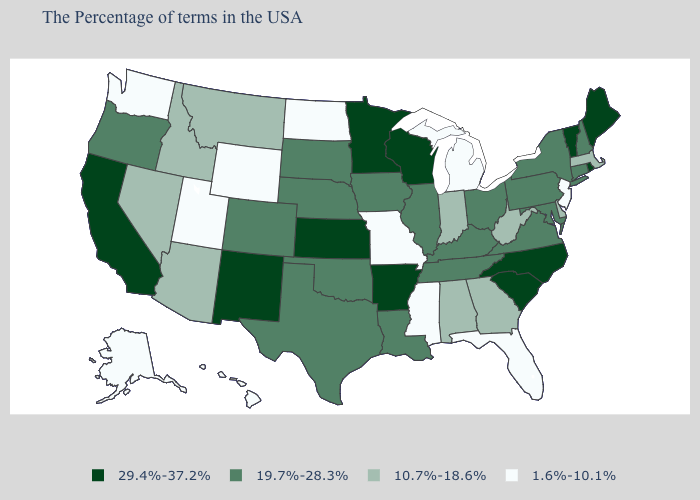What is the value of Ohio?
Keep it brief. 19.7%-28.3%. What is the lowest value in states that border Alabama?
Quick response, please. 1.6%-10.1%. Among the states that border South Carolina , does Georgia have the highest value?
Answer briefly. No. Name the states that have a value in the range 19.7%-28.3%?
Concise answer only. New Hampshire, Connecticut, New York, Maryland, Pennsylvania, Virginia, Ohio, Kentucky, Tennessee, Illinois, Louisiana, Iowa, Nebraska, Oklahoma, Texas, South Dakota, Colorado, Oregon. Name the states that have a value in the range 10.7%-18.6%?
Concise answer only. Massachusetts, Delaware, West Virginia, Georgia, Indiana, Alabama, Montana, Arizona, Idaho, Nevada. Name the states that have a value in the range 10.7%-18.6%?
Be succinct. Massachusetts, Delaware, West Virginia, Georgia, Indiana, Alabama, Montana, Arizona, Idaho, Nevada. What is the value of Nebraska?
Answer briefly. 19.7%-28.3%. Which states have the lowest value in the USA?
Write a very short answer. New Jersey, Florida, Michigan, Mississippi, Missouri, North Dakota, Wyoming, Utah, Washington, Alaska, Hawaii. Does South Carolina have the highest value in the USA?
Answer briefly. Yes. Which states have the lowest value in the USA?
Write a very short answer. New Jersey, Florida, Michigan, Mississippi, Missouri, North Dakota, Wyoming, Utah, Washington, Alaska, Hawaii. What is the highest value in states that border Oklahoma?
Keep it brief. 29.4%-37.2%. Among the states that border New York , does New Jersey have the highest value?
Concise answer only. No. What is the value of Utah?
Concise answer only. 1.6%-10.1%. What is the value of South Carolina?
Answer briefly. 29.4%-37.2%. Name the states that have a value in the range 19.7%-28.3%?
Write a very short answer. New Hampshire, Connecticut, New York, Maryland, Pennsylvania, Virginia, Ohio, Kentucky, Tennessee, Illinois, Louisiana, Iowa, Nebraska, Oklahoma, Texas, South Dakota, Colorado, Oregon. 